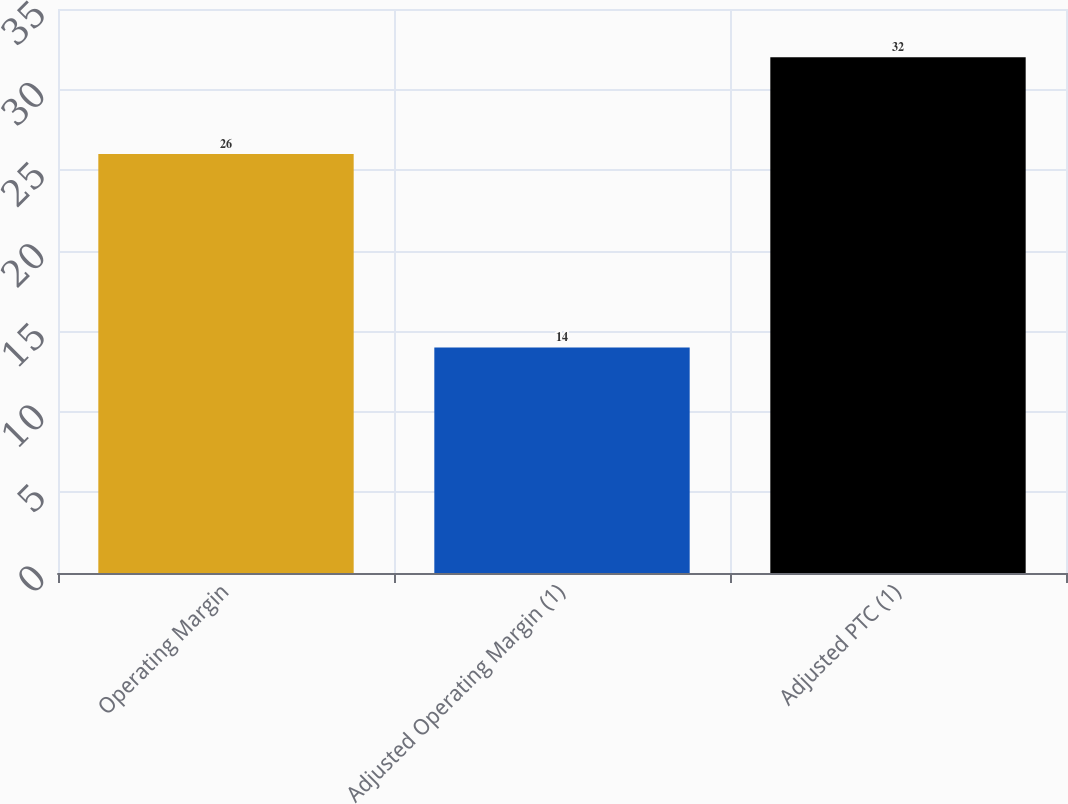<chart> <loc_0><loc_0><loc_500><loc_500><bar_chart><fcel>Operating Margin<fcel>Adjusted Operating Margin (1)<fcel>Adjusted PTC (1)<nl><fcel>26<fcel>14<fcel>32<nl></chart> 